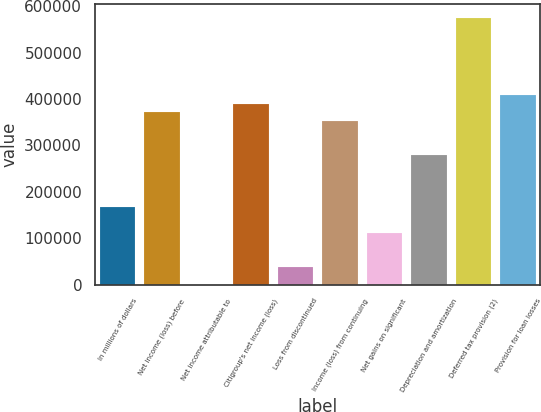Convert chart to OTSL. <chart><loc_0><loc_0><loc_500><loc_500><bar_chart><fcel>In millions of dollars<fcel>Net income (loss) before<fcel>Net income attributable to<fcel>Citigroup's net income (loss)<fcel>Loss from discontinued<fcel>Income (loss) from continuing<fcel>Net gains on significant<fcel>Depreciation and amortization<fcel>Deferred tax provision (2)<fcel>Provision for loan losses<nl><fcel>167172<fcel>371420<fcel>60<fcel>389988<fcel>37196<fcel>352852<fcel>111468<fcel>278580<fcel>575668<fcel>408556<nl></chart> 